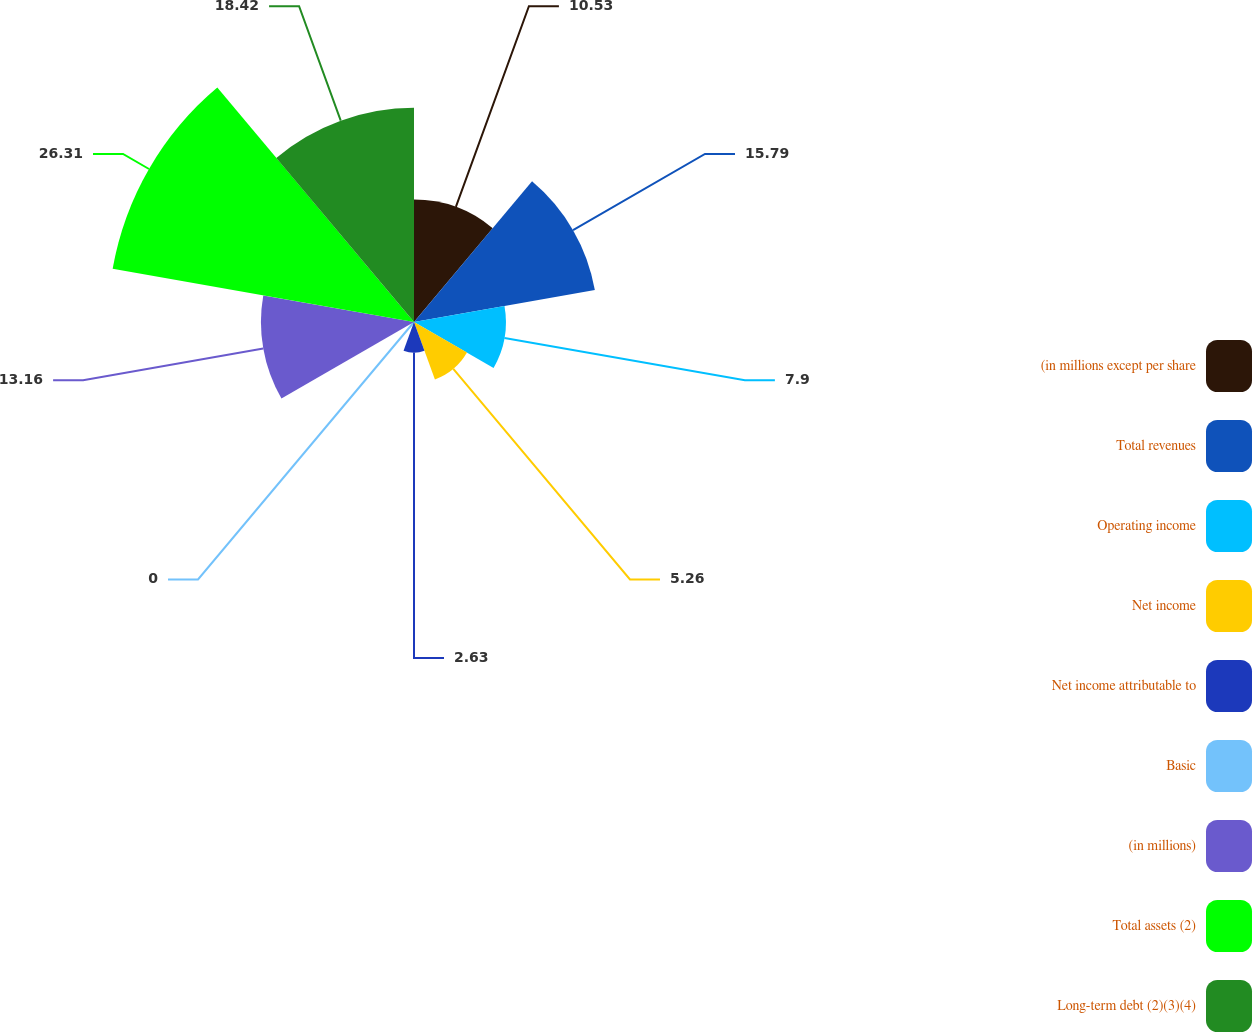Convert chart to OTSL. <chart><loc_0><loc_0><loc_500><loc_500><pie_chart><fcel>(in millions except per share<fcel>Total revenues<fcel>Operating income<fcel>Net income<fcel>Net income attributable to<fcel>Basic<fcel>(in millions)<fcel>Total assets (2)<fcel>Long-term debt (2)(3)(4)<nl><fcel>10.53%<fcel>15.79%<fcel>7.9%<fcel>5.26%<fcel>2.63%<fcel>0.0%<fcel>13.16%<fcel>26.31%<fcel>18.42%<nl></chart> 